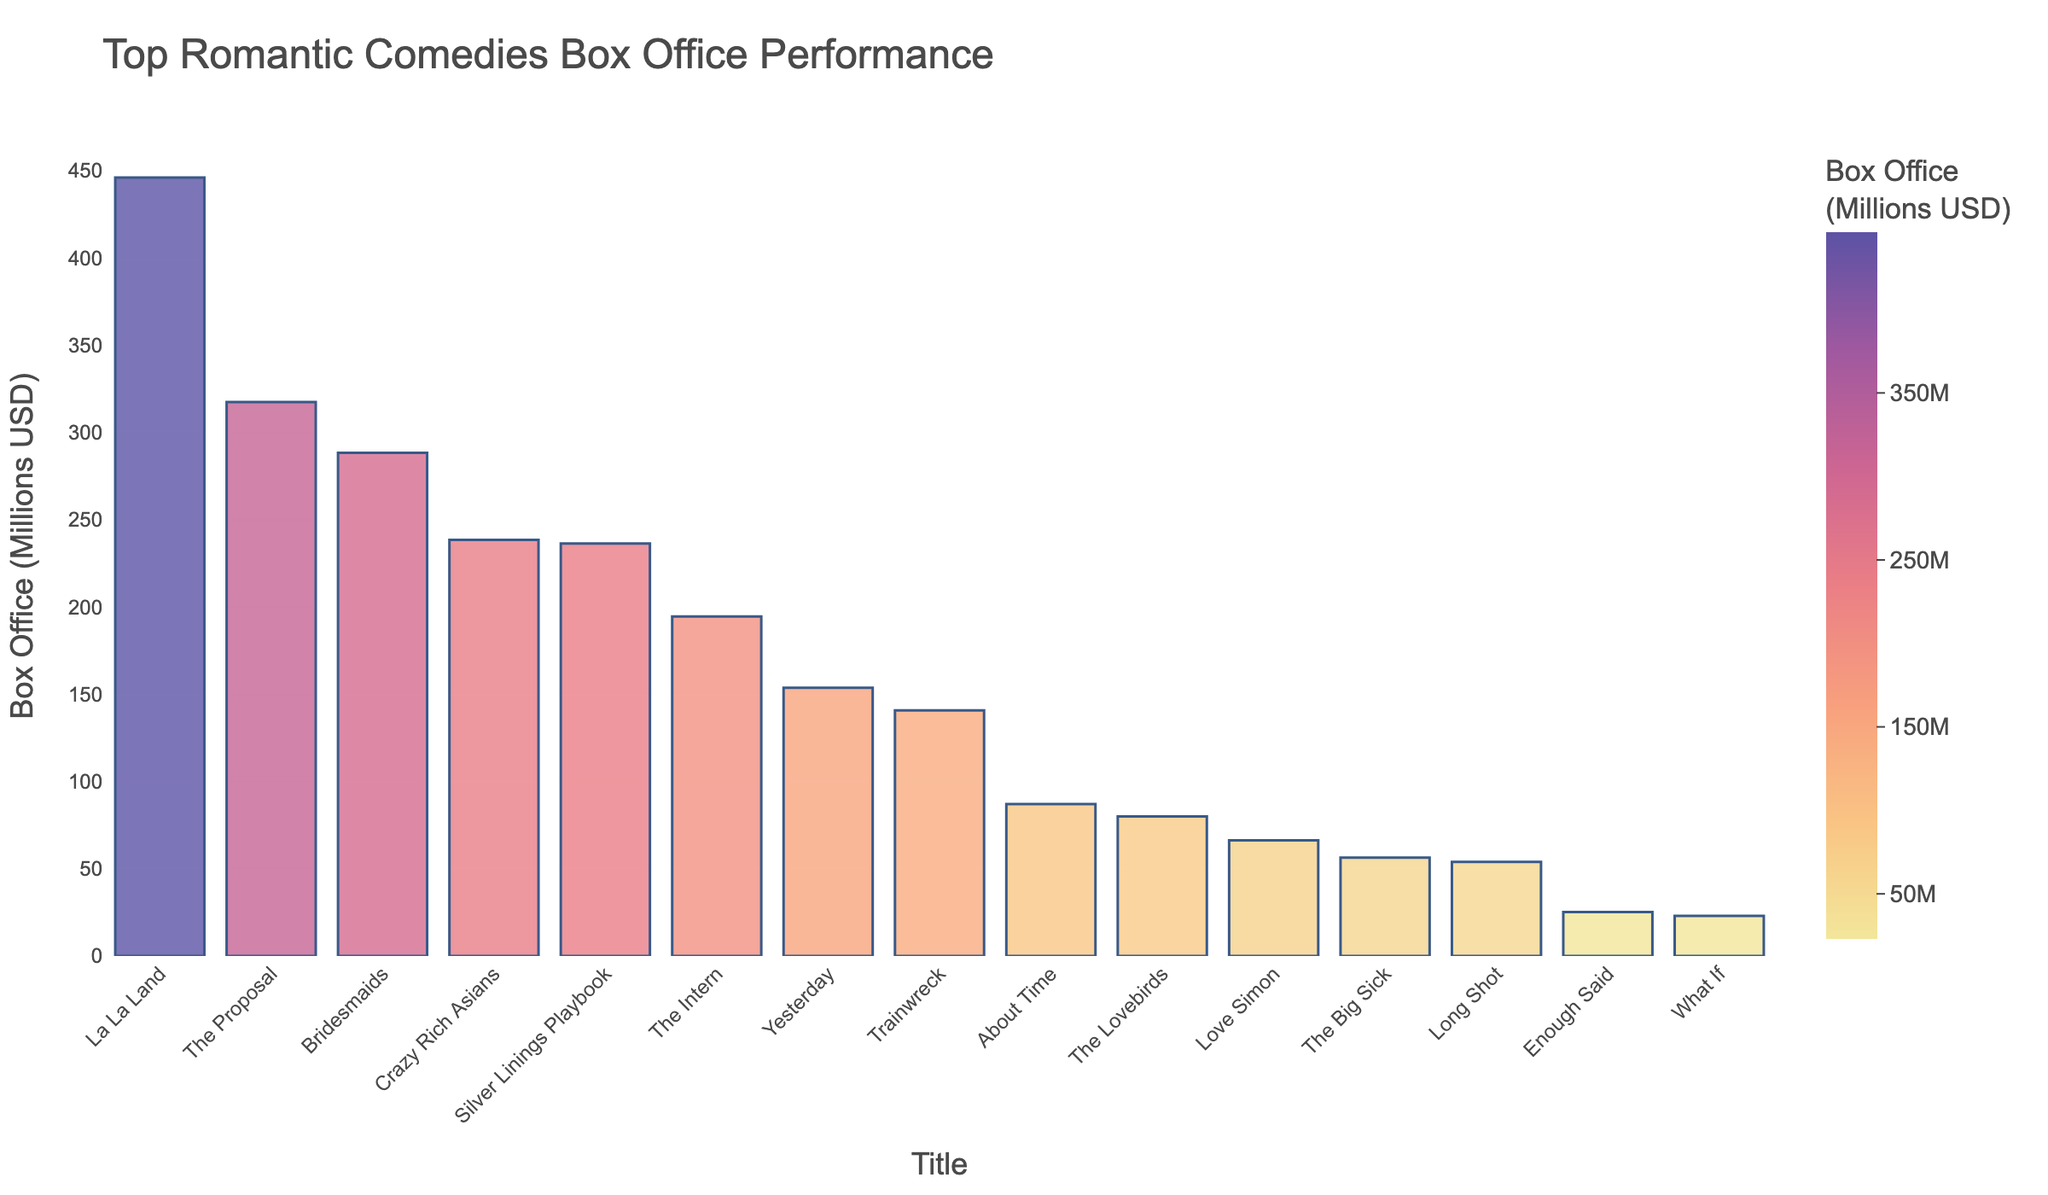How many romantic comedies have a box office performance exceeding 200 million USD? There are 5 bars with box office values exceeding 200 million USD, namely: "La La Land", "The Proposal", "Crazy Rich Asians", "Bridesmaids", and "Silver Linings Playbook".
Answer: 5 Which romantic comedy had the highest box office performance, and what was its value? "La La Land" had the highest box office performance with 446.1 million USD.
Answer: La La Land, 446.1 million USD What is the total box office revenue of "The Big Sick", "Love Simon", and "Yesterday"? The box office of "The Big Sick" is 56.4 million USD, "Love Simon" is 66.3 million USD, and "Yesterday" is 153.7 million USD. Summing them: 56.4 + 66.3 + 153.7 = 276.4 million USD.
Answer: 276.4 million USD Among the titles listed, which one has the lowest box office performance? The movie with the lowest box office performance is "What If" with 23.0 million USD.
Answer: What If, 23.0 million USD How much higher is the box office revenue of "Bridesmaids" compared to "The Intern"? "Bridesmaids" made 288.4 million USD, while "The Intern" made 194.6 million USD. The difference is 288.4 - 194.6 = 93.8 million USD.
Answer: 93.8 million USD What is the average box office performance of the top 3 movies? The top 3 movies are "La La Land" (446.1 M), "The Proposal" (317.4 M), and "Crazy Rich Asians" (238.5 M). The sum is 446.1 + 317.4 + 238.5 = 1002 million USD. The average is 1002 / 3 = 334 million USD.
Answer: 334 million USD Which movie performed better at the box office, "Trainwreck" or "About Time"? "Trainwreck" had a box office of 140.8 million USD and "About Time" had 87.1 million USD. Since 140.8 > 87.1, "Trainwreck" performed better.
Answer: Trainwreck How many movies have a box office between 50 million and 100 million USD? The movies within this range are "The Big Sick" (56.4 M), "About Time" (87.1 M), "Love Simon" (66.3 M), "The Lovebirds" (80.0 M). There are 4 such movies.
Answer: 4 What is the sum of box office revenue for the two lowest-grossing movies? The two lowest-grossing movies are "What If" (23.0 M) and "Enough Said" (25.2 M). The sum is 23.0 + 25.2 = 48.2 million USD.
Answer: 48.2 million USD Which movie has a box office closest to the median value of all listed romantic comedies? To find the median, arrange all values in ascending order and find the middle value. Arranged: 23.0, 25.2, 53.9, 56.4, 66.3, 80.0, 87.1, 140.8, 153.7, 194.6, 236.4, 238.5, 288.4, 317.4, 446.1. The middle value is 87.1, corresponding to "About Time".
Answer: About Time 